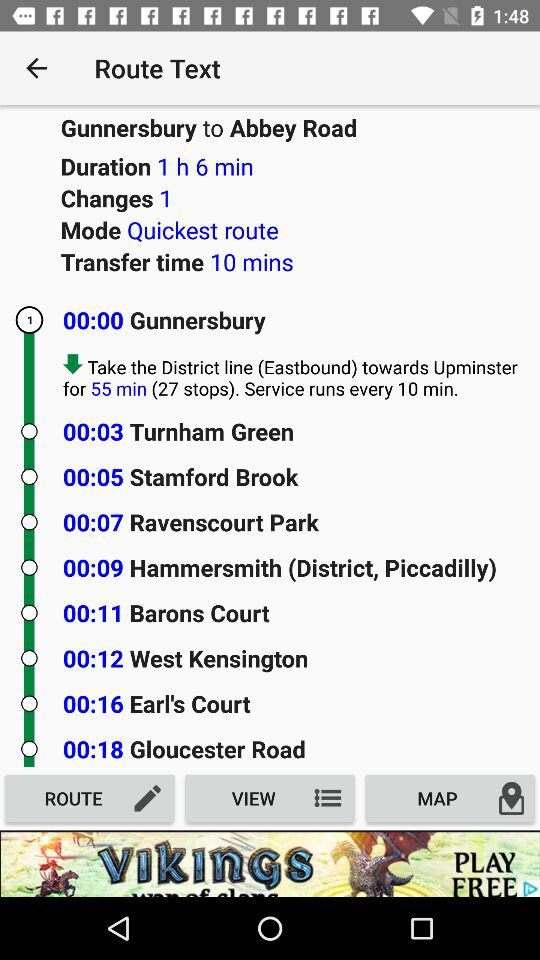What is the travel duration from Gunnersbury to Abbey Road? The travel duration from Gunnersbury to Abbey Road is 1 hour 6 minutes. 